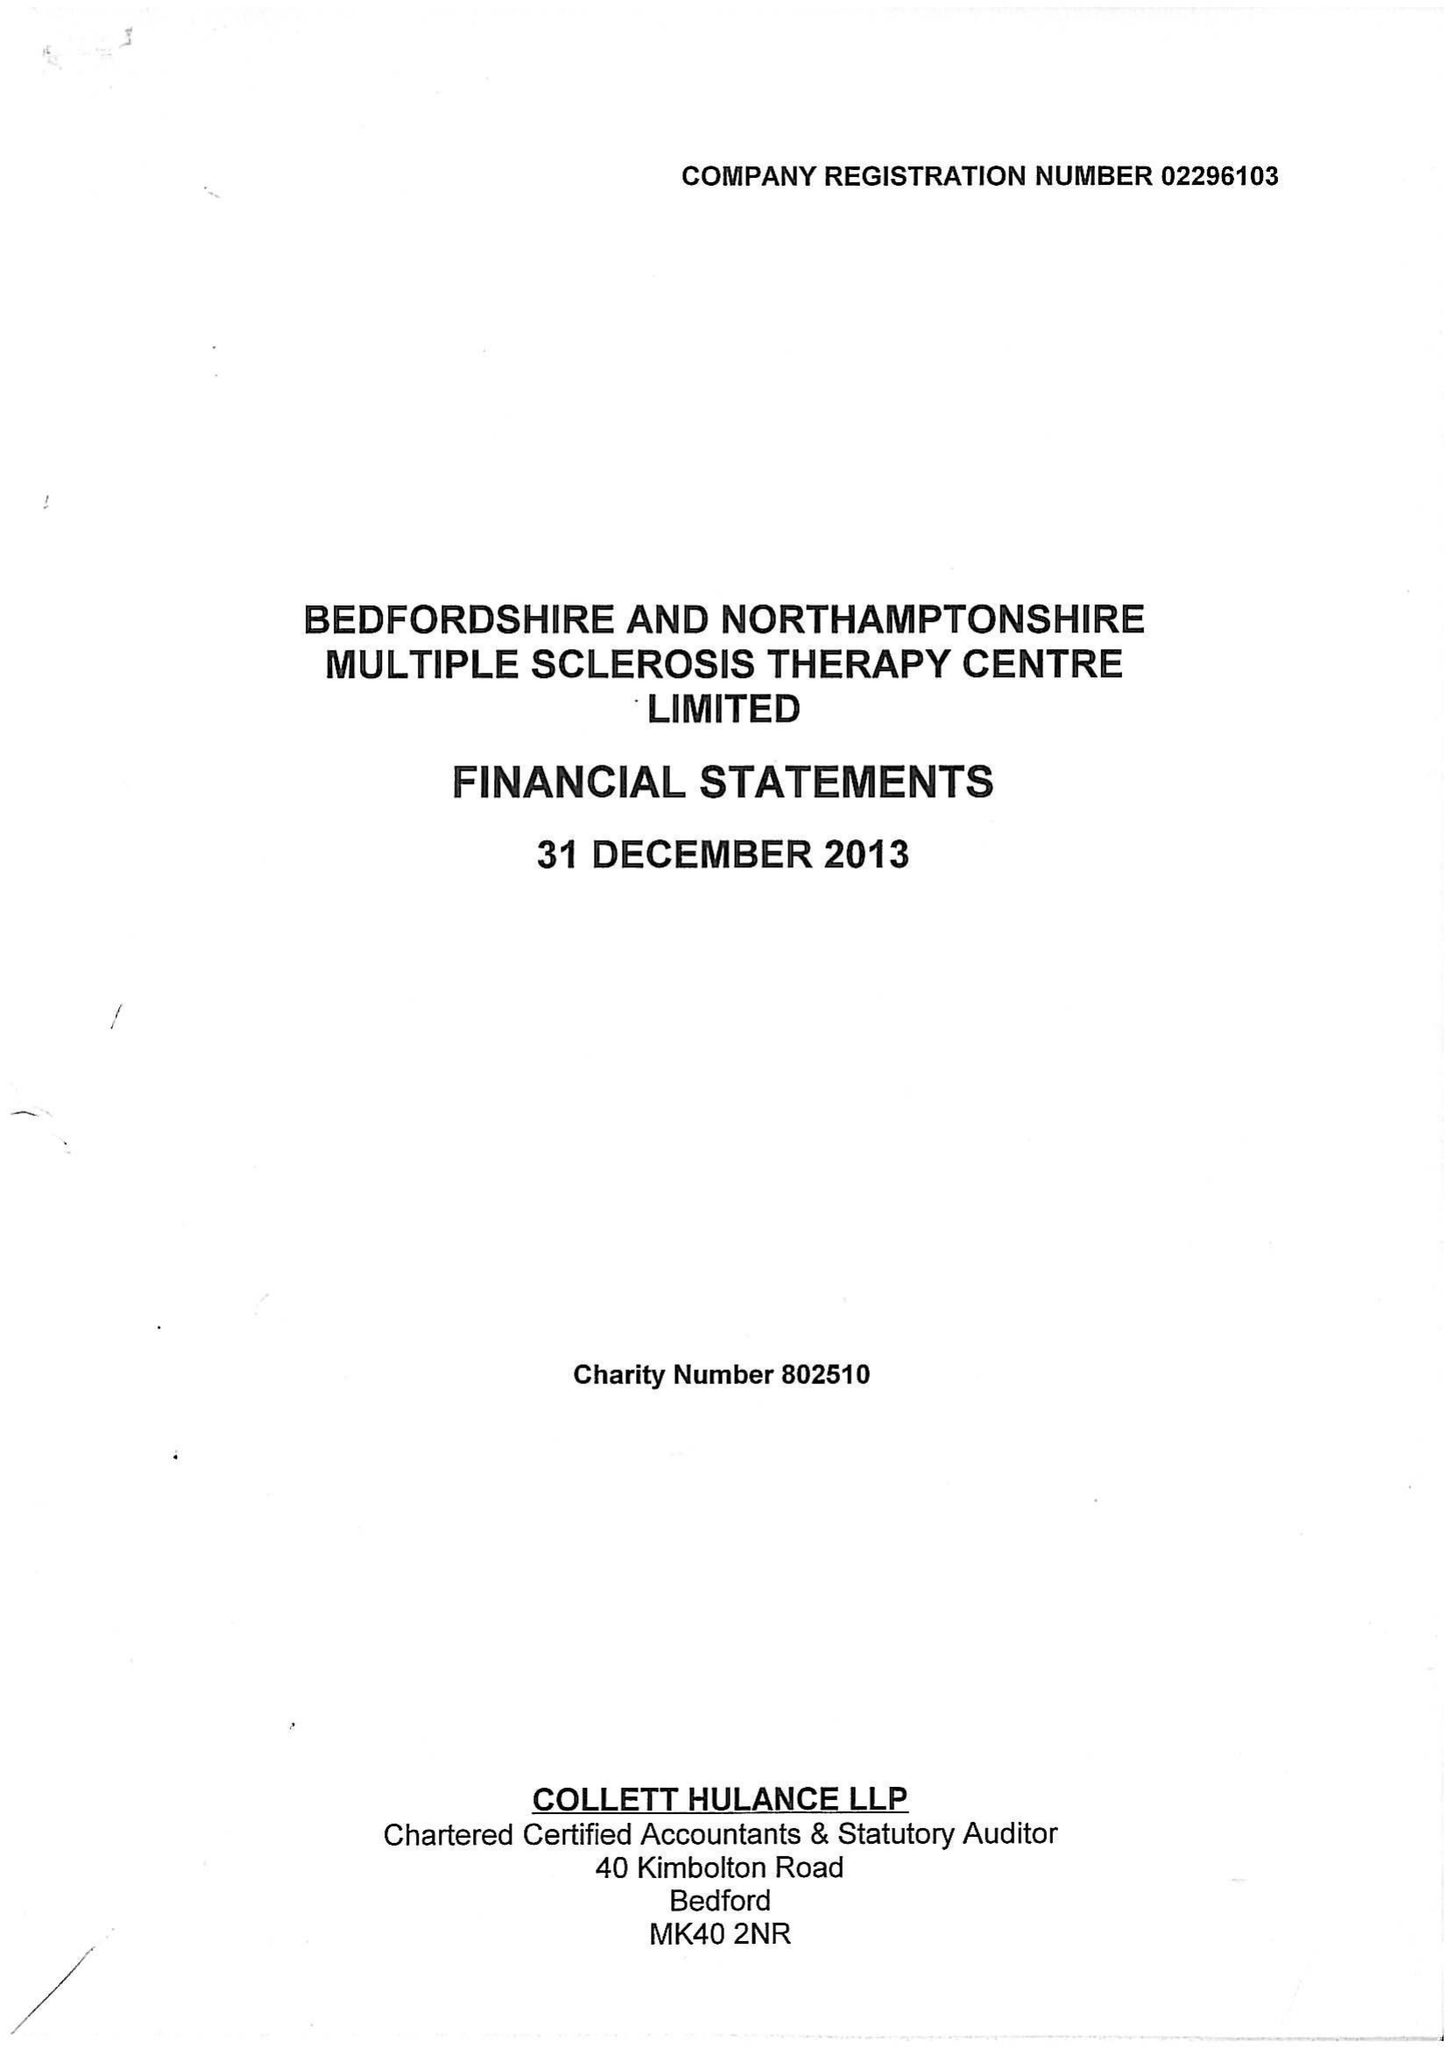What is the value for the address__street_line?
Answer the question using a single word or phrase. BARKERS LANE 